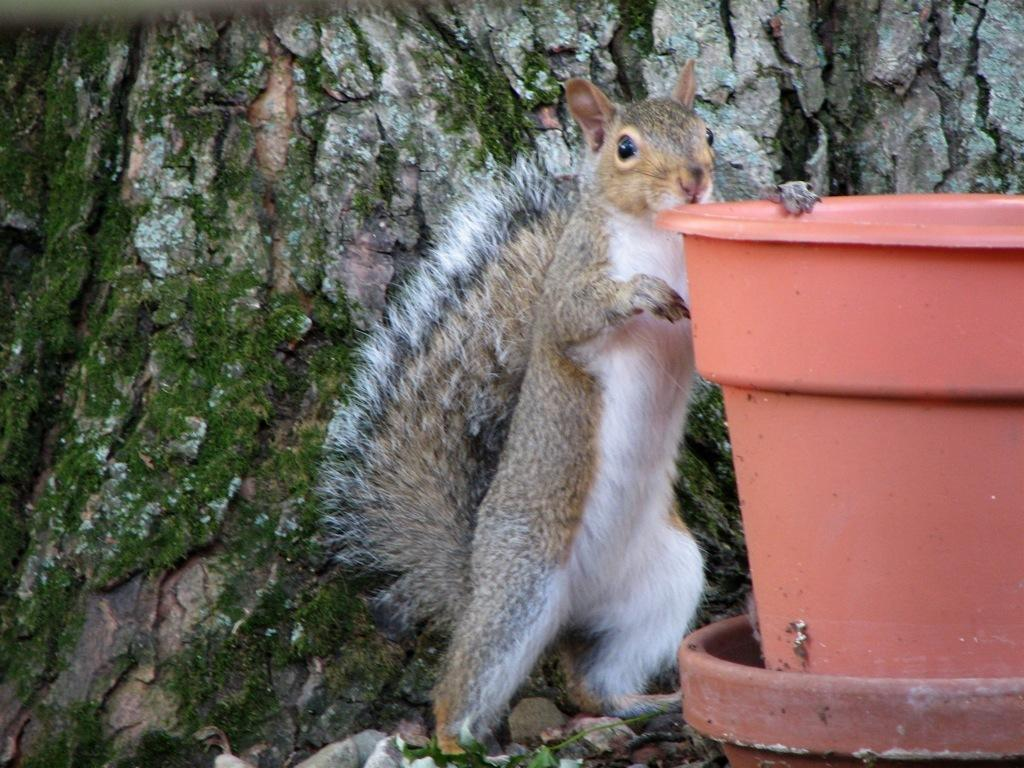What animal can be seen in the image? There is a squirrel in the image. What is the squirrel doing in the image? The squirrel is standing and holding a pot. How many pots are visible in the image? There are two pots in the image. What can be found on the ground in the image? There are leaves and stones on the ground in the image. What is present in the background of the image? There is a big tree stump in the background of the image. What type of boat is visible in the image? There is no boat present in the image. How does the squirrel's temper affect its ability to hold the pot in the image? The squirrel's temper is not mentioned in the image, and therefore it cannot be determined how it affects the squirrel's ability to hold the pot. 